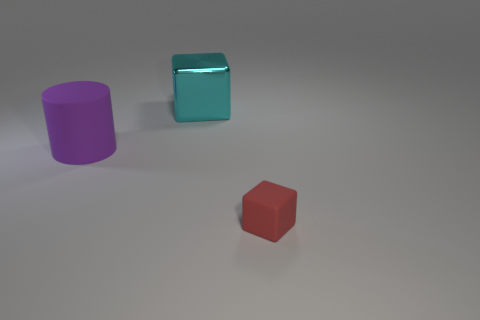Add 2 matte cylinders. How many objects exist? 5 Subtract all cylinders. How many objects are left? 2 Add 2 big purple objects. How many big purple objects exist? 3 Subtract 1 cyan blocks. How many objects are left? 2 Subtract all cylinders. Subtract all tiny green shiny objects. How many objects are left? 2 Add 2 red objects. How many red objects are left? 3 